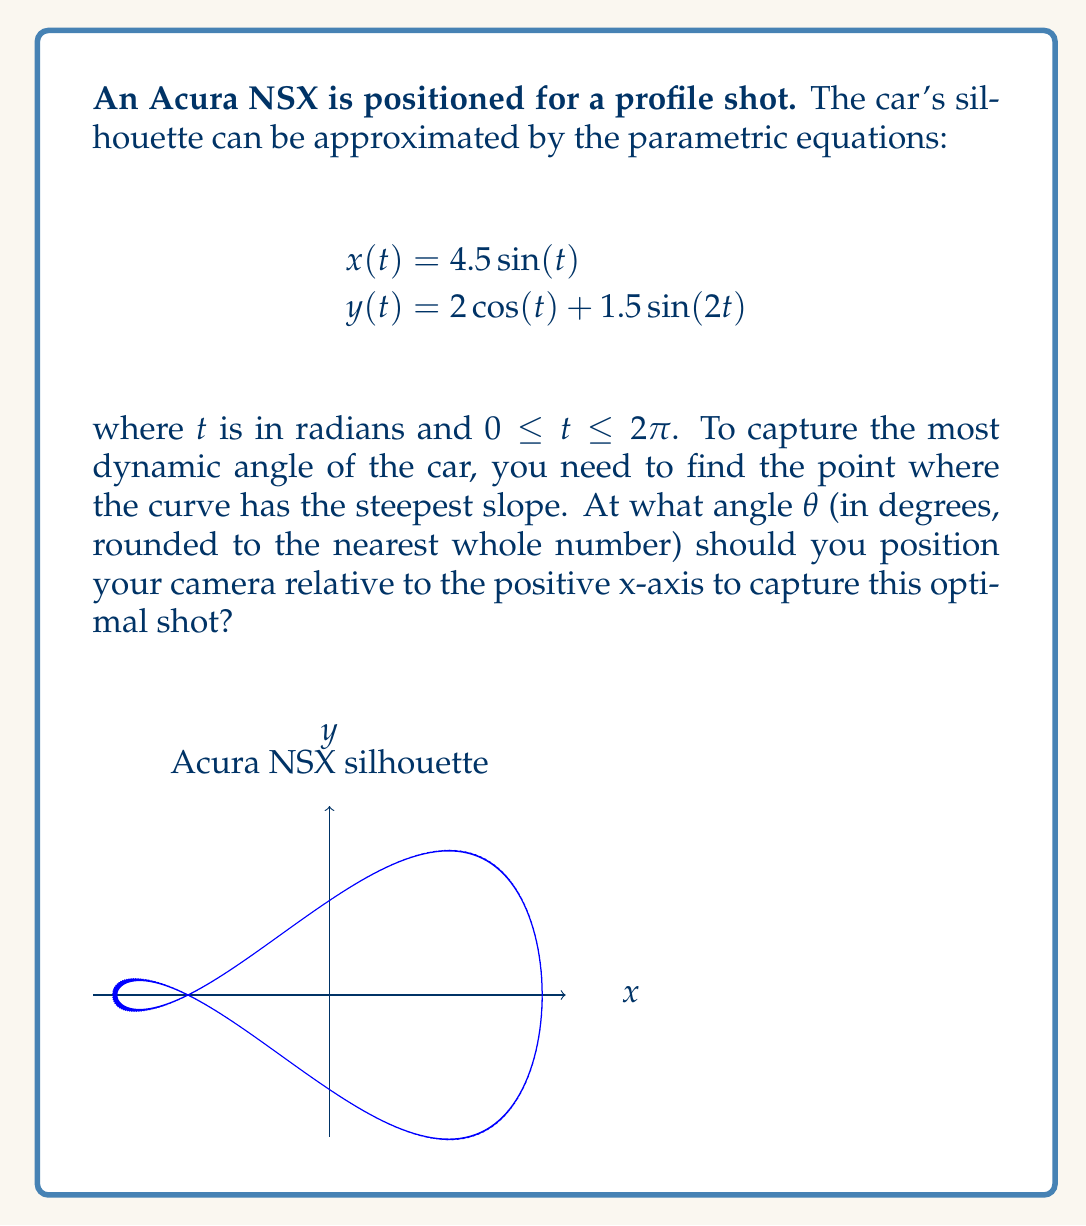What is the answer to this math problem? To find the steepest slope, we need to follow these steps:

1) Calculate the derivatives of x and y with respect to t:
   $$\frac{dx}{dt} = 4.5\cos(t)$$
   $$\frac{dy}{dt} = -2\sin(t) + 3\cos(2t)$$

2) The slope of the curve at any point is given by:
   $$\frac{dy}{dx} = \frac{dy/dt}{dx/dt} = \frac{-2\sin(t) + 3\cos(2t)}{4.5\cos(t)}$$

3) To find the steepest slope, we need to maximize the absolute value of dy/dx. This occurs when the numerator is at its maximum and the denominator is close to zero (but not exactly zero).

4) The denominator $4.5\cos(t)$ is close to zero when $t$ is close to $\pi/2$ or $3\pi/2$.

5) Let's examine the numerator near these points:
   At $t = \pi/2$: $-2\sin(\pi/2) + 3\cos(\pi) = -2 - 3 = -5$
   At $t = 3\pi/2$: $-2\sin(3\pi/2) + 3\cos(3\pi) = 2 - 3 = -1$

6) The larger absolute value occurs at $t = \pi/2$, so this is where the slope is steepest.

7) At $t = \pi/2$, $x = 4.5$ and $y = -2$.

8) The angle $\theta$ relative to the positive x-axis is:
   $$\theta = \arctan(\frac{y}{x}) = \arctan(\frac{-2}{4.5}) \approx -23.96°$$

9) Converting to a positive angle (as cameras are typically positioned):
   $$\theta = 180° - 23.96° = 156.04°$$

10) Rounding to the nearest whole number: 156°
Answer: 156° 